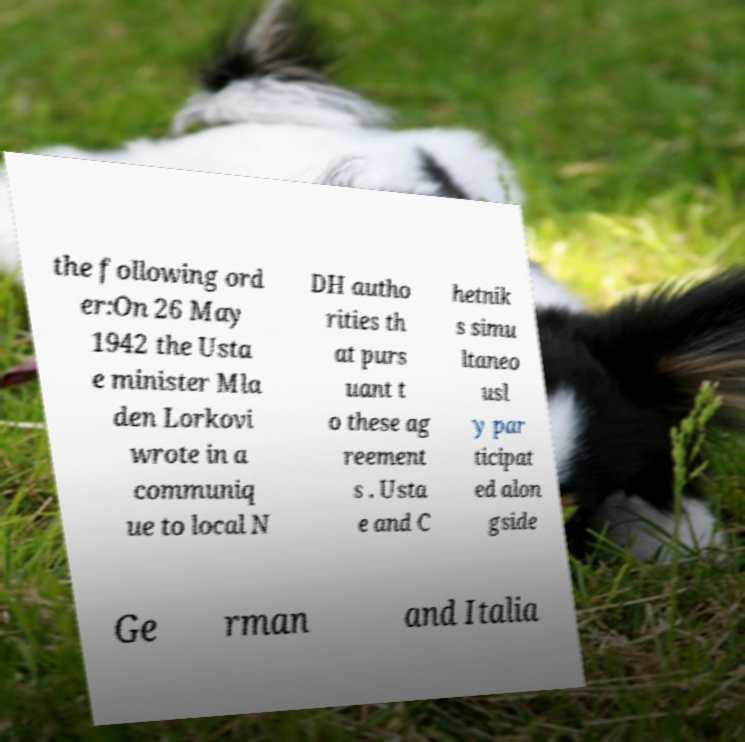Could you assist in decoding the text presented in this image and type it out clearly? the following ord er:On 26 May 1942 the Usta e minister Mla den Lorkovi wrote in a communiq ue to local N DH autho rities th at purs uant t o these ag reement s . Usta e and C hetnik s simu ltaneo usl y par ticipat ed alon gside Ge rman and Italia 